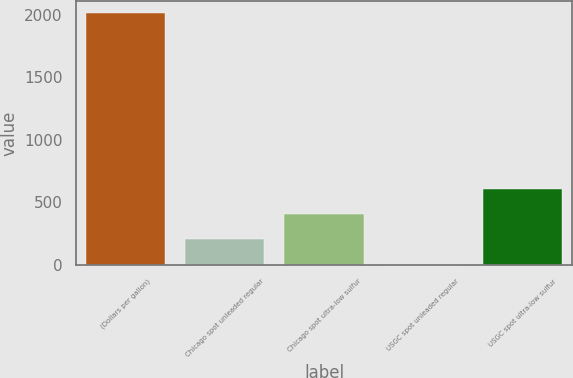Convert chart. <chart><loc_0><loc_0><loc_500><loc_500><bar_chart><fcel>(Dollars per gallon)<fcel>Chicago spot unleaded regular<fcel>Chicago spot ultra-low sulfur<fcel>USGC spot unleaded regular<fcel>USGC spot ultra-low sulfur<nl><fcel>2012<fcel>203.73<fcel>404.65<fcel>2.81<fcel>605.57<nl></chart> 